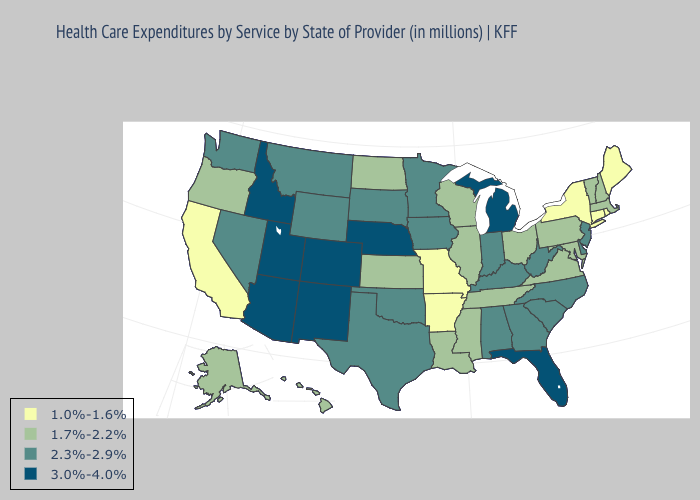Name the states that have a value in the range 1.7%-2.2%?
Quick response, please. Alaska, Hawaii, Illinois, Kansas, Louisiana, Maryland, Massachusetts, Mississippi, New Hampshire, North Dakota, Ohio, Oregon, Pennsylvania, Tennessee, Vermont, Virginia, Wisconsin. Does Oklahoma have a higher value than Massachusetts?
Answer briefly. Yes. Which states have the lowest value in the USA?
Concise answer only. Arkansas, California, Connecticut, Maine, Missouri, New York, Rhode Island. Name the states that have a value in the range 1.7%-2.2%?
Quick response, please. Alaska, Hawaii, Illinois, Kansas, Louisiana, Maryland, Massachusetts, Mississippi, New Hampshire, North Dakota, Ohio, Oregon, Pennsylvania, Tennessee, Vermont, Virginia, Wisconsin. What is the value of North Carolina?
Give a very brief answer. 2.3%-2.9%. Which states have the lowest value in the South?
Quick response, please. Arkansas. Name the states that have a value in the range 3.0%-4.0%?
Write a very short answer. Arizona, Colorado, Florida, Idaho, Michigan, Nebraska, New Mexico, Utah. Does New Jersey have the highest value in the USA?
Keep it brief. No. What is the lowest value in states that border Nevada?
Quick response, please. 1.0%-1.6%. Which states have the highest value in the USA?
Concise answer only. Arizona, Colorado, Florida, Idaho, Michigan, Nebraska, New Mexico, Utah. Does Minnesota have the highest value in the MidWest?
Short answer required. No. Is the legend a continuous bar?
Short answer required. No. Name the states that have a value in the range 1.7%-2.2%?
Answer briefly. Alaska, Hawaii, Illinois, Kansas, Louisiana, Maryland, Massachusetts, Mississippi, New Hampshire, North Dakota, Ohio, Oregon, Pennsylvania, Tennessee, Vermont, Virginia, Wisconsin. What is the value of Washington?
Answer briefly. 2.3%-2.9%. What is the highest value in states that border Ohio?
Answer briefly. 3.0%-4.0%. 